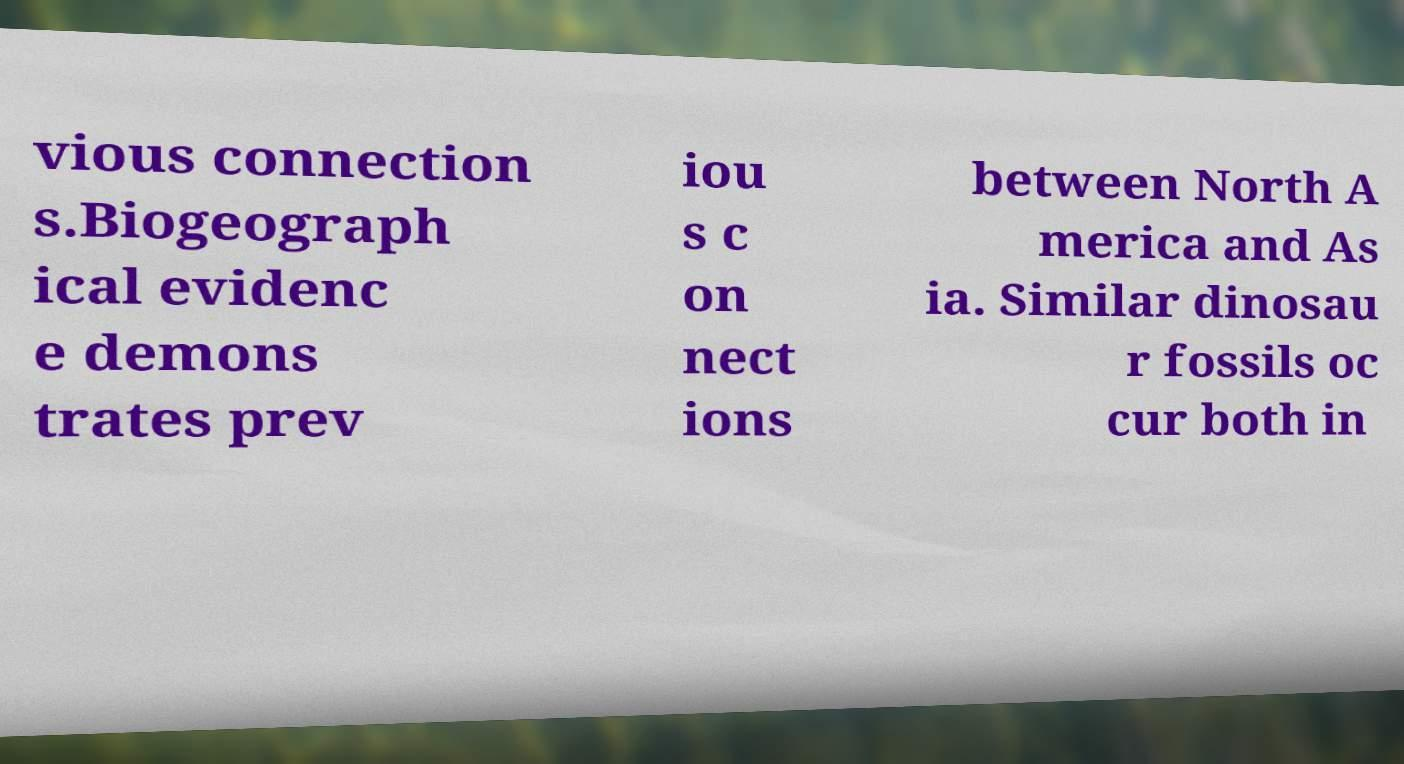For documentation purposes, I need the text within this image transcribed. Could you provide that? vious connection s.Biogeograph ical evidenc e demons trates prev iou s c on nect ions between North A merica and As ia. Similar dinosau r fossils oc cur both in 